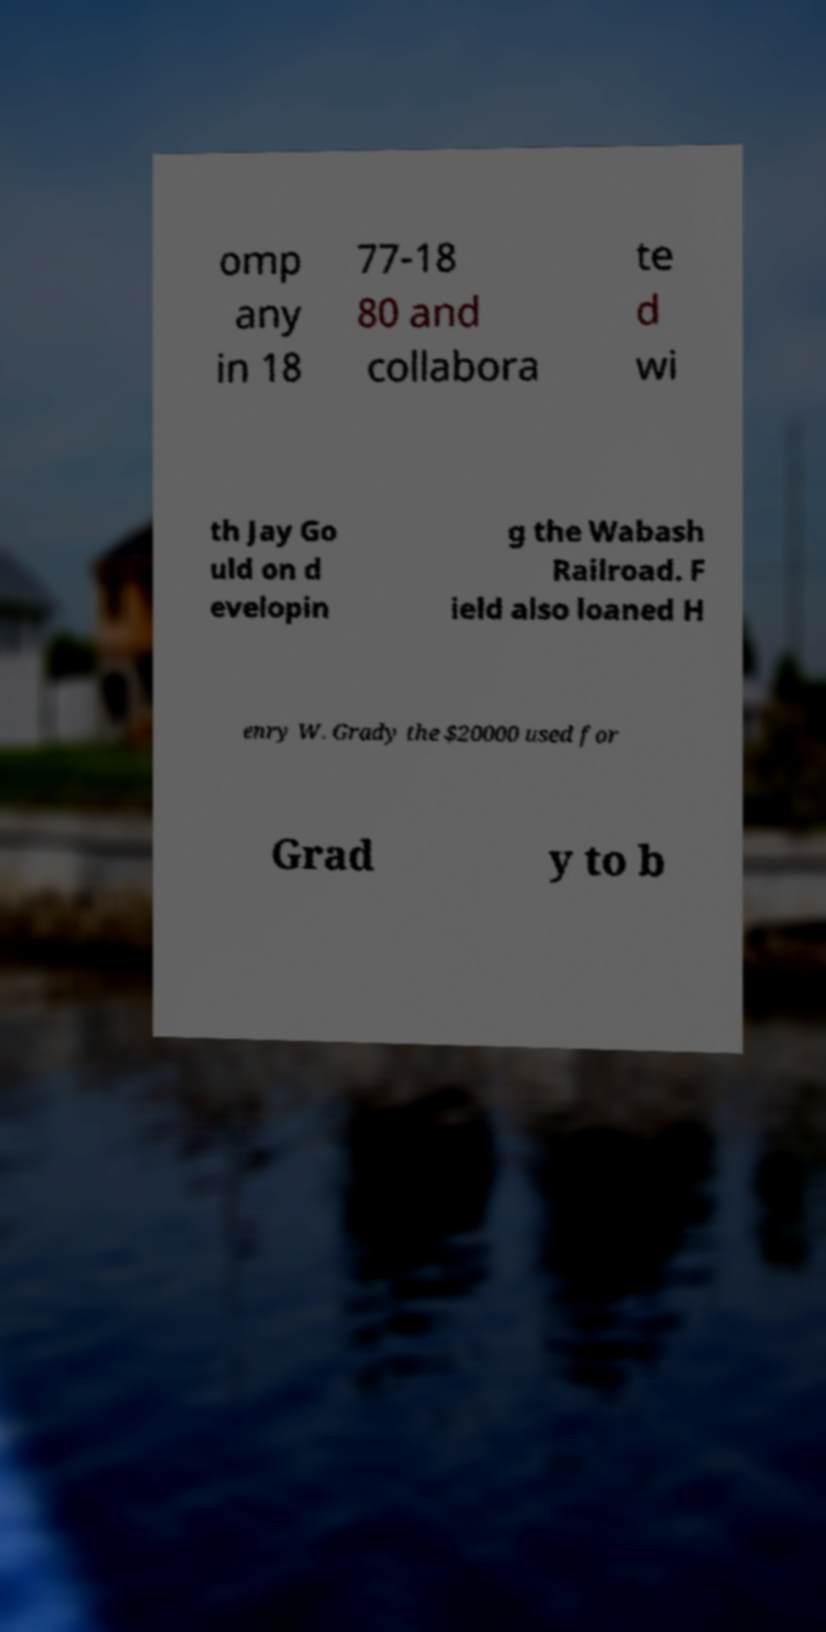There's text embedded in this image that I need extracted. Can you transcribe it verbatim? omp any in 18 77-18 80 and collabora te d wi th Jay Go uld on d evelopin g the Wabash Railroad. F ield also loaned H enry W. Grady the $20000 used for Grad y to b 